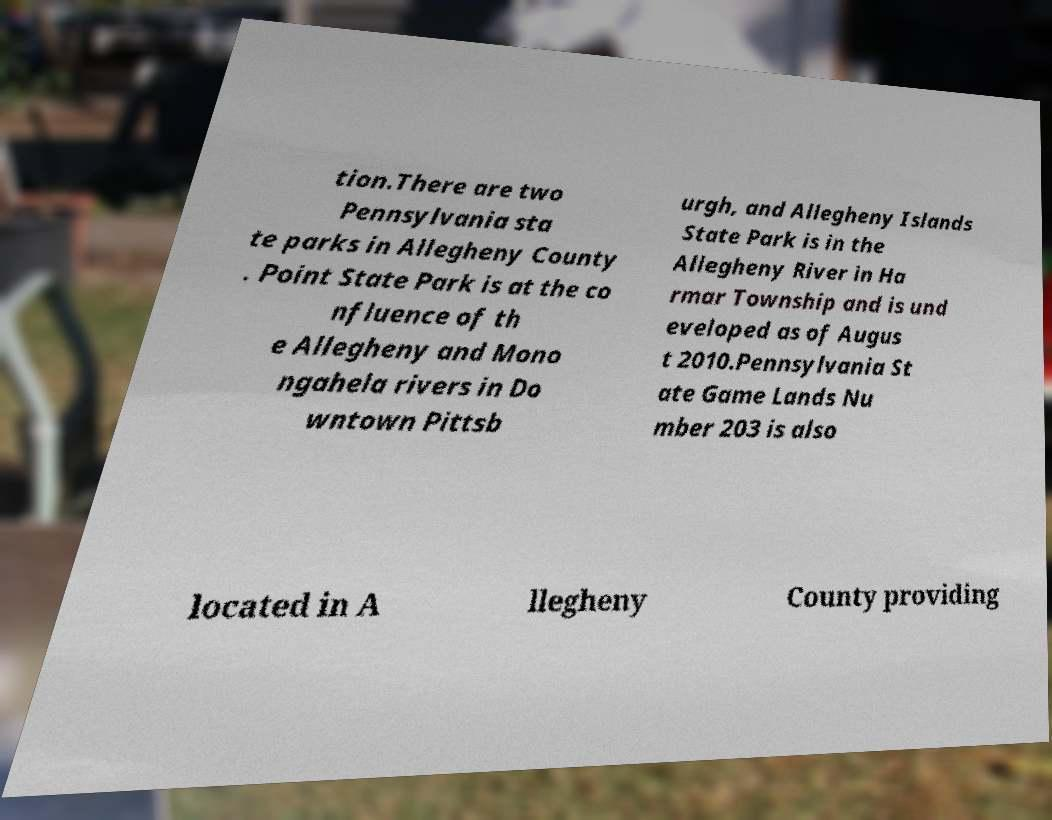What messages or text are displayed in this image? I need them in a readable, typed format. tion.There are two Pennsylvania sta te parks in Allegheny County . Point State Park is at the co nfluence of th e Allegheny and Mono ngahela rivers in Do wntown Pittsb urgh, and Allegheny Islands State Park is in the Allegheny River in Ha rmar Township and is und eveloped as of Augus t 2010.Pennsylvania St ate Game Lands Nu mber 203 is also located in A llegheny County providing 